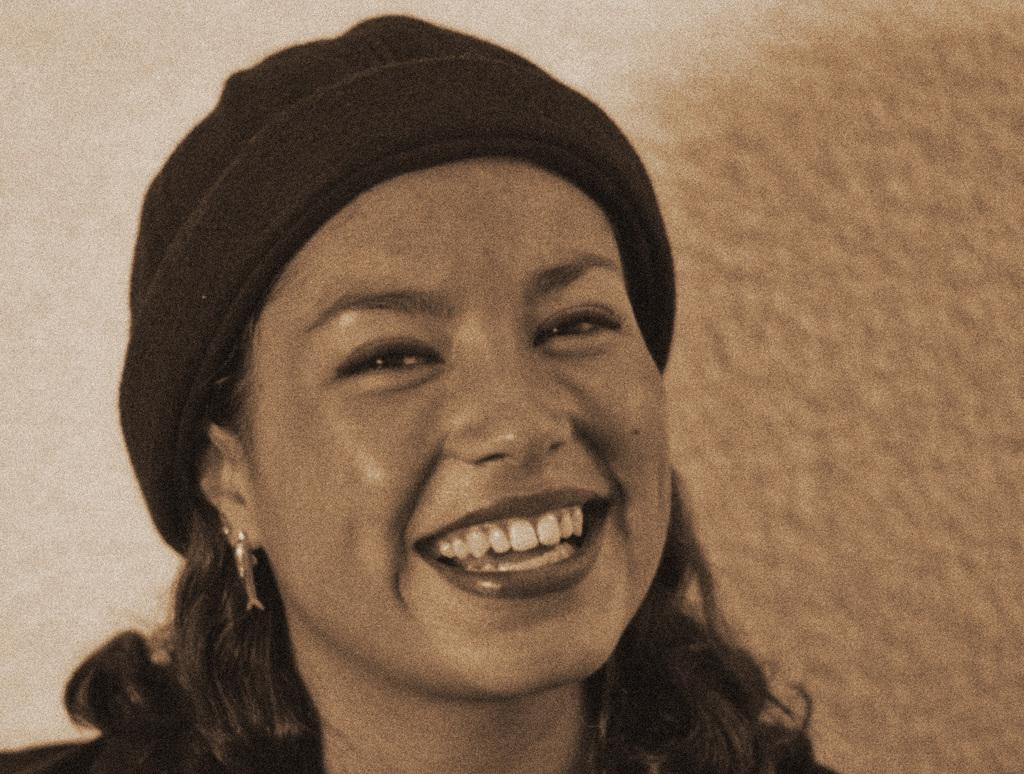Who is the main subject in the image? There is a person in the center of the image. What is the person doing in the image? The person is smiling. What accessory is the person wearing in the image? The person is wearing a hat. What can be seen in the background of the image? There is a wall in the background of the image. How does the person maintain their balance while using a toothbrush in the image? There is no toothbrush present in the image, and the person's balance is not relevant to the image. 